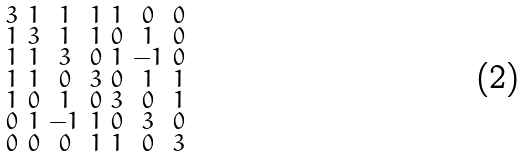Convert formula to latex. <formula><loc_0><loc_0><loc_500><loc_500>\begin{smallmatrix} 3 & 1 & 1 & 1 & 1 & 0 & 0 \\ 1 & 3 & 1 & 1 & 0 & 1 & 0 \\ 1 & 1 & 3 & 0 & 1 & - 1 & 0 \\ 1 & 1 & 0 & 3 & 0 & 1 & 1 \\ 1 & 0 & 1 & 0 & 3 & 0 & 1 \\ 0 & 1 & - 1 & 1 & 0 & 3 & 0 \\ 0 & 0 & 0 & 1 & 1 & 0 & 3 \end{smallmatrix}</formula> 